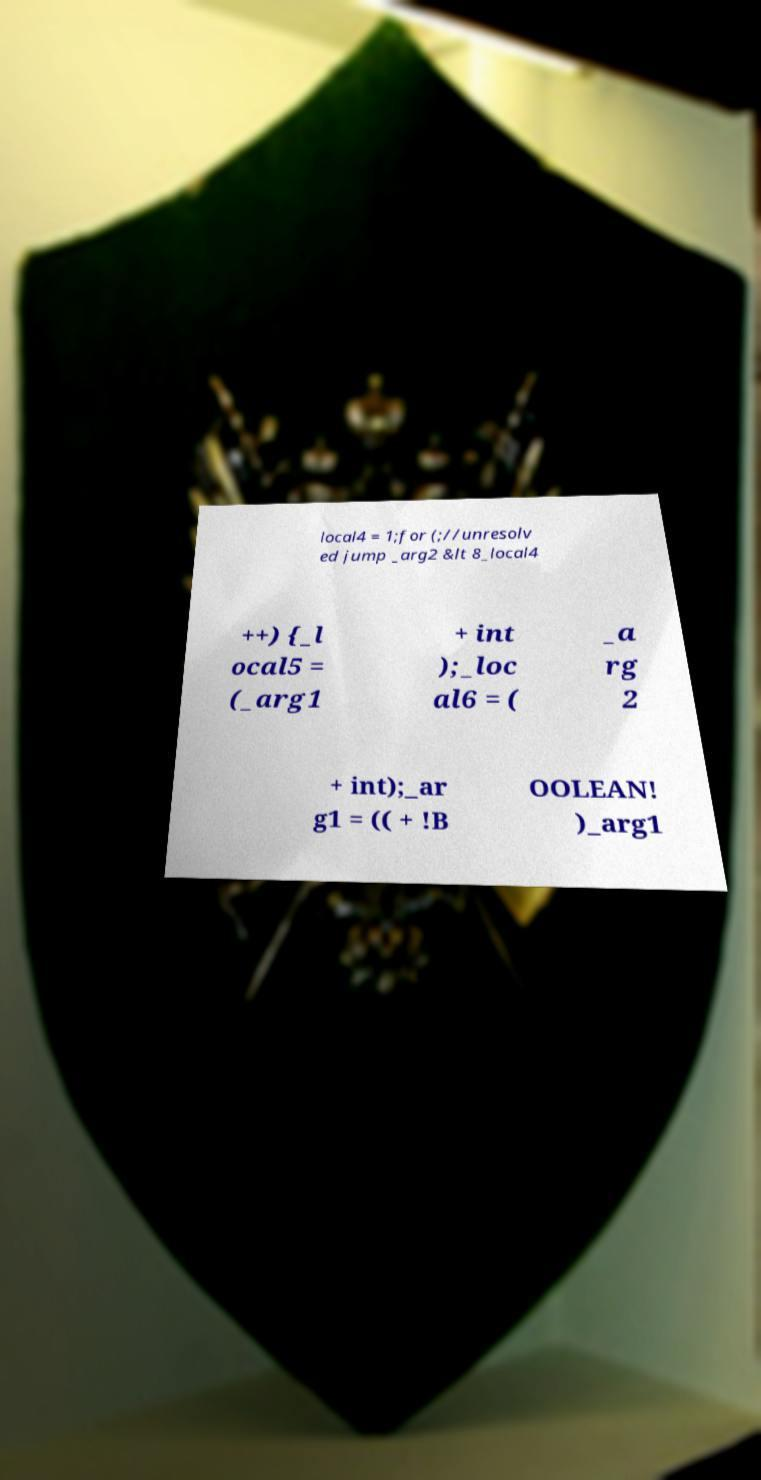There's text embedded in this image that I need extracted. Can you transcribe it verbatim? local4 = 1;for (;//unresolv ed jump _arg2 &lt 8_local4 ++) {_l ocal5 = (_arg1 + int );_loc al6 = ( _a rg 2 + int);_ar g1 = (( + !B OOLEAN! )_arg1 